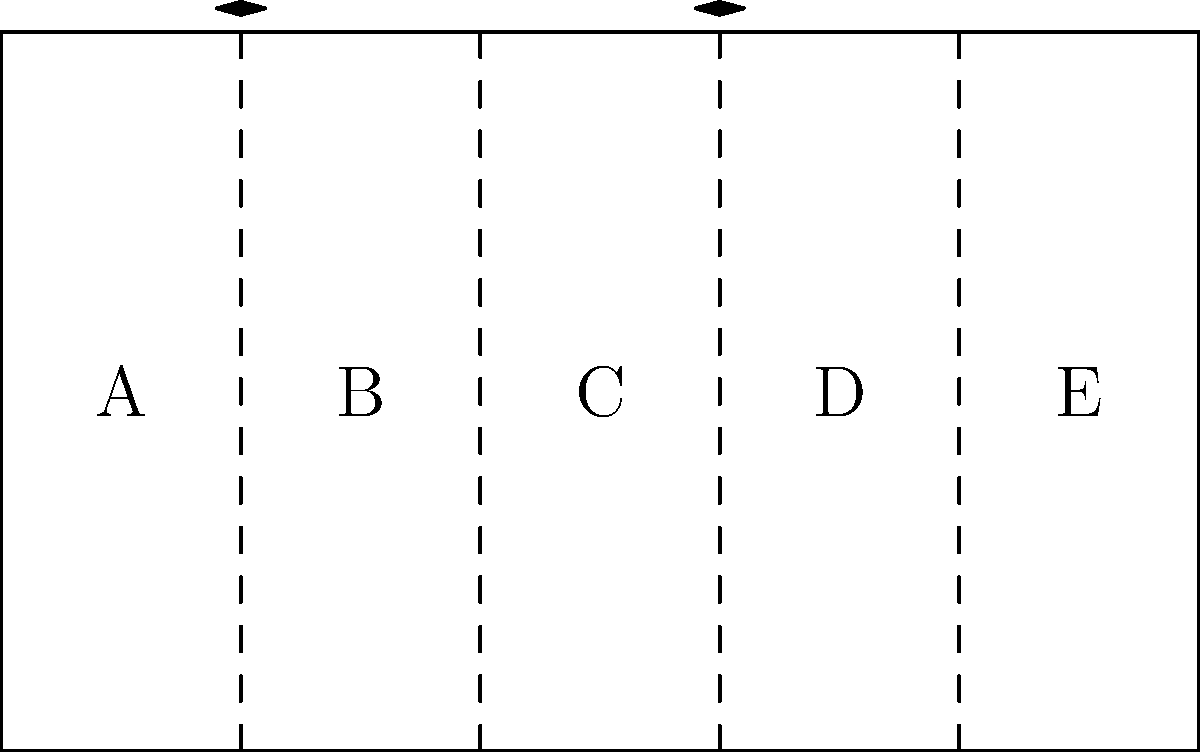Hey, sound guru! Check out this mixing board layout. It's like a band lineup, but with knobs instead of hipsters. Which sections are playing the same tune, if you catch my drift? Alright, let's break this down like we're dissecting a killer guitar solo:

1) We've got a mixing board divided into five sections, labeled A, B, C, D, and E.

2) In geometry, when we say sections are congruent, we mean they're identical in shape and size. It's like when two guitarists are playing the exact same riff.

3) Looking at the diagram, we can see some sneaky little double-headed arrows above the dividing lines. These arrows are the universal symbol for "these things are the same size," kind of like how a devil horns hand sign means "this rocks" at a gig.

4) We've got these arrows between sections A and B, and between sections C and D.

5) This means that section A is congruent to section B, and section C is congruent to section D.

6) Section E is left out in the cold, like that one band member who always shows up late to practice.

So, if we're looking for the congruent sections, we've got two pairs: A and B, and C and D.
Answer: A ≅ B, C ≅ D 